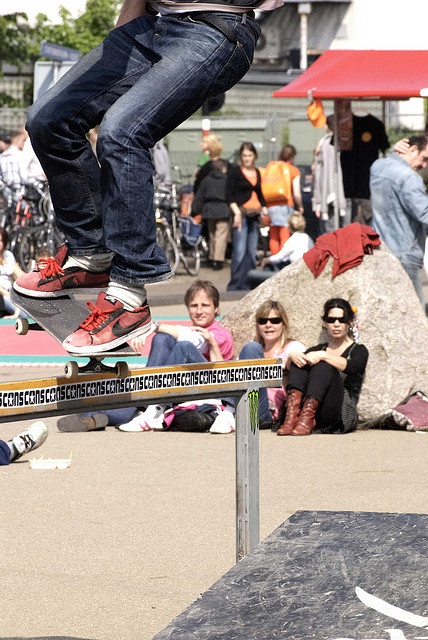Describe the objects in this image and their specific colors. I can see people in white, black, gray, and darkgray tones, people in white, black, brown, gray, and ivory tones, people in white, darkgray, lightgray, and gray tones, people in white, gray, and lightpink tones, and people in white, brown, black, and gray tones in this image. 